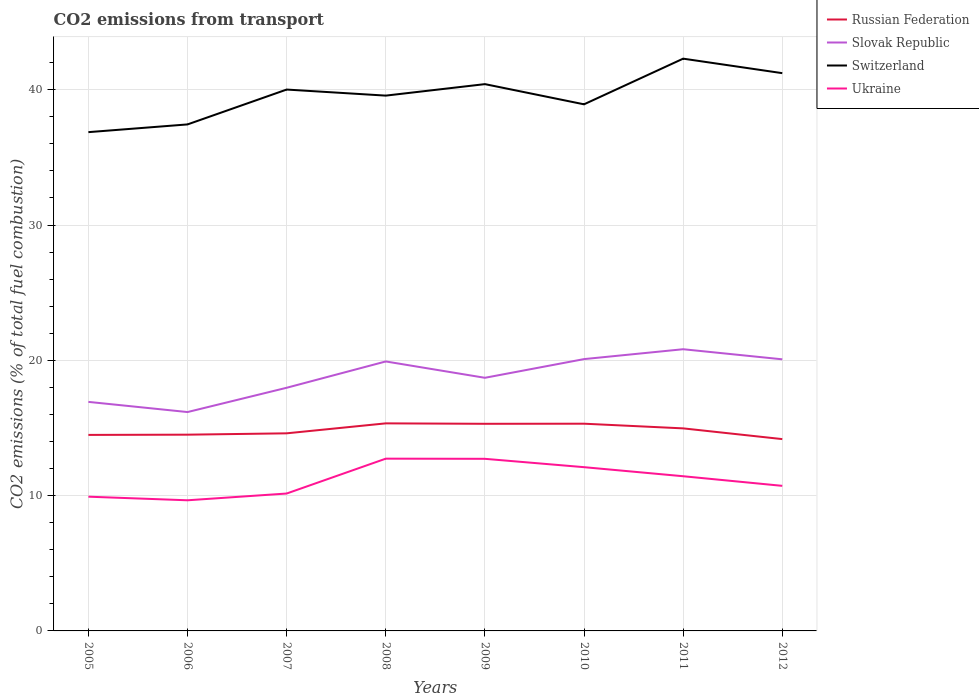How many different coloured lines are there?
Offer a terse response. 4. Does the line corresponding to Ukraine intersect with the line corresponding to Slovak Republic?
Your response must be concise. No. Is the number of lines equal to the number of legend labels?
Your response must be concise. Yes. Across all years, what is the maximum total CO2 emitted in Russian Federation?
Your response must be concise. 14.18. What is the total total CO2 emitted in Switzerland in the graph?
Keep it short and to the point. -2.58. What is the difference between the highest and the second highest total CO2 emitted in Switzerland?
Your response must be concise. 5.43. What is the difference between the highest and the lowest total CO2 emitted in Slovak Republic?
Your answer should be compact. 4. Is the total CO2 emitted in Switzerland strictly greater than the total CO2 emitted in Ukraine over the years?
Provide a succinct answer. No. How many lines are there?
Keep it short and to the point. 4. How many years are there in the graph?
Offer a very short reply. 8. Are the values on the major ticks of Y-axis written in scientific E-notation?
Make the answer very short. No. Does the graph contain any zero values?
Provide a short and direct response. No. Does the graph contain grids?
Ensure brevity in your answer.  Yes. Where does the legend appear in the graph?
Offer a very short reply. Top right. What is the title of the graph?
Give a very brief answer. CO2 emissions from transport. Does "Faeroe Islands" appear as one of the legend labels in the graph?
Give a very brief answer. No. What is the label or title of the Y-axis?
Offer a terse response. CO2 emissions (% of total fuel combustion). What is the CO2 emissions (% of total fuel combustion) in Russian Federation in 2005?
Offer a very short reply. 14.49. What is the CO2 emissions (% of total fuel combustion) in Slovak Republic in 2005?
Give a very brief answer. 16.93. What is the CO2 emissions (% of total fuel combustion) of Switzerland in 2005?
Keep it short and to the point. 36.87. What is the CO2 emissions (% of total fuel combustion) in Ukraine in 2005?
Your response must be concise. 9.92. What is the CO2 emissions (% of total fuel combustion) in Russian Federation in 2006?
Your answer should be compact. 14.51. What is the CO2 emissions (% of total fuel combustion) in Slovak Republic in 2006?
Your answer should be compact. 16.18. What is the CO2 emissions (% of total fuel combustion) of Switzerland in 2006?
Offer a terse response. 37.44. What is the CO2 emissions (% of total fuel combustion) in Ukraine in 2006?
Your response must be concise. 9.66. What is the CO2 emissions (% of total fuel combustion) in Russian Federation in 2007?
Give a very brief answer. 14.61. What is the CO2 emissions (% of total fuel combustion) in Slovak Republic in 2007?
Offer a very short reply. 17.97. What is the CO2 emissions (% of total fuel combustion) of Switzerland in 2007?
Offer a terse response. 40.01. What is the CO2 emissions (% of total fuel combustion) in Ukraine in 2007?
Your answer should be very brief. 10.16. What is the CO2 emissions (% of total fuel combustion) of Russian Federation in 2008?
Give a very brief answer. 15.34. What is the CO2 emissions (% of total fuel combustion) in Slovak Republic in 2008?
Your answer should be compact. 19.92. What is the CO2 emissions (% of total fuel combustion) of Switzerland in 2008?
Give a very brief answer. 39.57. What is the CO2 emissions (% of total fuel combustion) of Ukraine in 2008?
Your answer should be very brief. 12.73. What is the CO2 emissions (% of total fuel combustion) of Russian Federation in 2009?
Offer a very short reply. 15.31. What is the CO2 emissions (% of total fuel combustion) of Slovak Republic in 2009?
Offer a very short reply. 18.71. What is the CO2 emissions (% of total fuel combustion) of Switzerland in 2009?
Your response must be concise. 40.42. What is the CO2 emissions (% of total fuel combustion) in Ukraine in 2009?
Keep it short and to the point. 12.72. What is the CO2 emissions (% of total fuel combustion) of Russian Federation in 2010?
Keep it short and to the point. 15.32. What is the CO2 emissions (% of total fuel combustion) in Slovak Republic in 2010?
Provide a succinct answer. 20.09. What is the CO2 emissions (% of total fuel combustion) of Switzerland in 2010?
Your answer should be compact. 38.92. What is the CO2 emissions (% of total fuel combustion) in Ukraine in 2010?
Offer a terse response. 12.1. What is the CO2 emissions (% of total fuel combustion) in Russian Federation in 2011?
Your answer should be compact. 14.97. What is the CO2 emissions (% of total fuel combustion) in Slovak Republic in 2011?
Offer a very short reply. 20.82. What is the CO2 emissions (% of total fuel combustion) in Switzerland in 2011?
Your answer should be compact. 42.3. What is the CO2 emissions (% of total fuel combustion) of Ukraine in 2011?
Your answer should be compact. 11.43. What is the CO2 emissions (% of total fuel combustion) in Russian Federation in 2012?
Provide a short and direct response. 14.18. What is the CO2 emissions (% of total fuel combustion) in Slovak Republic in 2012?
Your answer should be very brief. 20.08. What is the CO2 emissions (% of total fuel combustion) of Switzerland in 2012?
Give a very brief answer. 41.23. What is the CO2 emissions (% of total fuel combustion) of Ukraine in 2012?
Provide a short and direct response. 10.72. Across all years, what is the maximum CO2 emissions (% of total fuel combustion) of Russian Federation?
Keep it short and to the point. 15.34. Across all years, what is the maximum CO2 emissions (% of total fuel combustion) in Slovak Republic?
Keep it short and to the point. 20.82. Across all years, what is the maximum CO2 emissions (% of total fuel combustion) in Switzerland?
Offer a terse response. 42.3. Across all years, what is the maximum CO2 emissions (% of total fuel combustion) of Ukraine?
Provide a short and direct response. 12.73. Across all years, what is the minimum CO2 emissions (% of total fuel combustion) of Russian Federation?
Offer a terse response. 14.18. Across all years, what is the minimum CO2 emissions (% of total fuel combustion) in Slovak Republic?
Give a very brief answer. 16.18. Across all years, what is the minimum CO2 emissions (% of total fuel combustion) of Switzerland?
Your answer should be very brief. 36.87. Across all years, what is the minimum CO2 emissions (% of total fuel combustion) in Ukraine?
Offer a terse response. 9.66. What is the total CO2 emissions (% of total fuel combustion) in Russian Federation in the graph?
Provide a succinct answer. 118.72. What is the total CO2 emissions (% of total fuel combustion) of Slovak Republic in the graph?
Make the answer very short. 150.69. What is the total CO2 emissions (% of total fuel combustion) of Switzerland in the graph?
Your answer should be compact. 316.75. What is the total CO2 emissions (% of total fuel combustion) of Ukraine in the graph?
Ensure brevity in your answer.  89.45. What is the difference between the CO2 emissions (% of total fuel combustion) in Russian Federation in 2005 and that in 2006?
Ensure brevity in your answer.  -0.02. What is the difference between the CO2 emissions (% of total fuel combustion) of Slovak Republic in 2005 and that in 2006?
Provide a short and direct response. 0.75. What is the difference between the CO2 emissions (% of total fuel combustion) in Switzerland in 2005 and that in 2006?
Offer a terse response. -0.57. What is the difference between the CO2 emissions (% of total fuel combustion) in Ukraine in 2005 and that in 2006?
Your response must be concise. 0.27. What is the difference between the CO2 emissions (% of total fuel combustion) in Russian Federation in 2005 and that in 2007?
Provide a succinct answer. -0.12. What is the difference between the CO2 emissions (% of total fuel combustion) of Slovak Republic in 2005 and that in 2007?
Your answer should be very brief. -1.04. What is the difference between the CO2 emissions (% of total fuel combustion) of Switzerland in 2005 and that in 2007?
Offer a terse response. -3.15. What is the difference between the CO2 emissions (% of total fuel combustion) in Ukraine in 2005 and that in 2007?
Offer a terse response. -0.23. What is the difference between the CO2 emissions (% of total fuel combustion) of Russian Federation in 2005 and that in 2008?
Offer a very short reply. -0.85. What is the difference between the CO2 emissions (% of total fuel combustion) of Slovak Republic in 2005 and that in 2008?
Your answer should be very brief. -2.99. What is the difference between the CO2 emissions (% of total fuel combustion) of Switzerland in 2005 and that in 2008?
Your response must be concise. -2.7. What is the difference between the CO2 emissions (% of total fuel combustion) of Ukraine in 2005 and that in 2008?
Your answer should be compact. -2.81. What is the difference between the CO2 emissions (% of total fuel combustion) of Russian Federation in 2005 and that in 2009?
Keep it short and to the point. -0.82. What is the difference between the CO2 emissions (% of total fuel combustion) of Slovak Republic in 2005 and that in 2009?
Your response must be concise. -1.78. What is the difference between the CO2 emissions (% of total fuel combustion) of Switzerland in 2005 and that in 2009?
Provide a succinct answer. -3.55. What is the difference between the CO2 emissions (% of total fuel combustion) of Ukraine in 2005 and that in 2009?
Keep it short and to the point. -2.8. What is the difference between the CO2 emissions (% of total fuel combustion) in Russian Federation in 2005 and that in 2010?
Provide a succinct answer. -0.83. What is the difference between the CO2 emissions (% of total fuel combustion) of Slovak Republic in 2005 and that in 2010?
Your answer should be very brief. -3.16. What is the difference between the CO2 emissions (% of total fuel combustion) in Switzerland in 2005 and that in 2010?
Your response must be concise. -2.06. What is the difference between the CO2 emissions (% of total fuel combustion) of Ukraine in 2005 and that in 2010?
Keep it short and to the point. -2.18. What is the difference between the CO2 emissions (% of total fuel combustion) in Russian Federation in 2005 and that in 2011?
Provide a succinct answer. -0.48. What is the difference between the CO2 emissions (% of total fuel combustion) in Slovak Republic in 2005 and that in 2011?
Make the answer very short. -3.89. What is the difference between the CO2 emissions (% of total fuel combustion) of Switzerland in 2005 and that in 2011?
Give a very brief answer. -5.43. What is the difference between the CO2 emissions (% of total fuel combustion) of Ukraine in 2005 and that in 2011?
Your answer should be compact. -1.51. What is the difference between the CO2 emissions (% of total fuel combustion) in Russian Federation in 2005 and that in 2012?
Provide a short and direct response. 0.31. What is the difference between the CO2 emissions (% of total fuel combustion) of Slovak Republic in 2005 and that in 2012?
Make the answer very short. -3.15. What is the difference between the CO2 emissions (% of total fuel combustion) of Switzerland in 2005 and that in 2012?
Provide a short and direct response. -4.36. What is the difference between the CO2 emissions (% of total fuel combustion) of Ukraine in 2005 and that in 2012?
Your response must be concise. -0.8. What is the difference between the CO2 emissions (% of total fuel combustion) of Russian Federation in 2006 and that in 2007?
Offer a terse response. -0.1. What is the difference between the CO2 emissions (% of total fuel combustion) of Slovak Republic in 2006 and that in 2007?
Your response must be concise. -1.8. What is the difference between the CO2 emissions (% of total fuel combustion) of Switzerland in 2006 and that in 2007?
Offer a very short reply. -2.58. What is the difference between the CO2 emissions (% of total fuel combustion) in Ukraine in 2006 and that in 2007?
Offer a terse response. -0.5. What is the difference between the CO2 emissions (% of total fuel combustion) of Russian Federation in 2006 and that in 2008?
Give a very brief answer. -0.84. What is the difference between the CO2 emissions (% of total fuel combustion) of Slovak Republic in 2006 and that in 2008?
Your response must be concise. -3.74. What is the difference between the CO2 emissions (% of total fuel combustion) of Switzerland in 2006 and that in 2008?
Your answer should be very brief. -2.13. What is the difference between the CO2 emissions (% of total fuel combustion) in Ukraine in 2006 and that in 2008?
Provide a short and direct response. -3.08. What is the difference between the CO2 emissions (% of total fuel combustion) in Russian Federation in 2006 and that in 2009?
Offer a very short reply. -0.8. What is the difference between the CO2 emissions (% of total fuel combustion) in Slovak Republic in 2006 and that in 2009?
Provide a short and direct response. -2.53. What is the difference between the CO2 emissions (% of total fuel combustion) in Switzerland in 2006 and that in 2009?
Keep it short and to the point. -2.98. What is the difference between the CO2 emissions (% of total fuel combustion) of Ukraine in 2006 and that in 2009?
Provide a short and direct response. -3.06. What is the difference between the CO2 emissions (% of total fuel combustion) of Russian Federation in 2006 and that in 2010?
Make the answer very short. -0.81. What is the difference between the CO2 emissions (% of total fuel combustion) of Slovak Republic in 2006 and that in 2010?
Provide a succinct answer. -3.91. What is the difference between the CO2 emissions (% of total fuel combustion) of Switzerland in 2006 and that in 2010?
Your response must be concise. -1.49. What is the difference between the CO2 emissions (% of total fuel combustion) of Ukraine in 2006 and that in 2010?
Ensure brevity in your answer.  -2.45. What is the difference between the CO2 emissions (% of total fuel combustion) of Russian Federation in 2006 and that in 2011?
Offer a terse response. -0.47. What is the difference between the CO2 emissions (% of total fuel combustion) in Slovak Republic in 2006 and that in 2011?
Make the answer very short. -4.64. What is the difference between the CO2 emissions (% of total fuel combustion) of Switzerland in 2006 and that in 2011?
Offer a very short reply. -4.86. What is the difference between the CO2 emissions (% of total fuel combustion) in Ukraine in 2006 and that in 2011?
Make the answer very short. -1.78. What is the difference between the CO2 emissions (% of total fuel combustion) of Russian Federation in 2006 and that in 2012?
Your answer should be very brief. 0.33. What is the difference between the CO2 emissions (% of total fuel combustion) in Slovak Republic in 2006 and that in 2012?
Provide a short and direct response. -3.9. What is the difference between the CO2 emissions (% of total fuel combustion) of Switzerland in 2006 and that in 2012?
Your answer should be very brief. -3.79. What is the difference between the CO2 emissions (% of total fuel combustion) of Ukraine in 2006 and that in 2012?
Offer a very short reply. -1.07. What is the difference between the CO2 emissions (% of total fuel combustion) of Russian Federation in 2007 and that in 2008?
Your answer should be very brief. -0.74. What is the difference between the CO2 emissions (% of total fuel combustion) of Slovak Republic in 2007 and that in 2008?
Your answer should be compact. -1.95. What is the difference between the CO2 emissions (% of total fuel combustion) in Switzerland in 2007 and that in 2008?
Your response must be concise. 0.45. What is the difference between the CO2 emissions (% of total fuel combustion) in Ukraine in 2007 and that in 2008?
Make the answer very short. -2.58. What is the difference between the CO2 emissions (% of total fuel combustion) in Russian Federation in 2007 and that in 2009?
Provide a succinct answer. -0.7. What is the difference between the CO2 emissions (% of total fuel combustion) in Slovak Republic in 2007 and that in 2009?
Offer a terse response. -0.74. What is the difference between the CO2 emissions (% of total fuel combustion) in Switzerland in 2007 and that in 2009?
Give a very brief answer. -0.4. What is the difference between the CO2 emissions (% of total fuel combustion) in Ukraine in 2007 and that in 2009?
Give a very brief answer. -2.57. What is the difference between the CO2 emissions (% of total fuel combustion) of Russian Federation in 2007 and that in 2010?
Offer a terse response. -0.71. What is the difference between the CO2 emissions (% of total fuel combustion) in Slovak Republic in 2007 and that in 2010?
Keep it short and to the point. -2.12. What is the difference between the CO2 emissions (% of total fuel combustion) in Switzerland in 2007 and that in 2010?
Keep it short and to the point. 1.09. What is the difference between the CO2 emissions (% of total fuel combustion) of Ukraine in 2007 and that in 2010?
Keep it short and to the point. -1.95. What is the difference between the CO2 emissions (% of total fuel combustion) of Russian Federation in 2007 and that in 2011?
Provide a short and direct response. -0.37. What is the difference between the CO2 emissions (% of total fuel combustion) in Slovak Republic in 2007 and that in 2011?
Provide a short and direct response. -2.85. What is the difference between the CO2 emissions (% of total fuel combustion) of Switzerland in 2007 and that in 2011?
Make the answer very short. -2.28. What is the difference between the CO2 emissions (% of total fuel combustion) in Ukraine in 2007 and that in 2011?
Keep it short and to the point. -1.28. What is the difference between the CO2 emissions (% of total fuel combustion) in Russian Federation in 2007 and that in 2012?
Provide a short and direct response. 0.43. What is the difference between the CO2 emissions (% of total fuel combustion) in Slovak Republic in 2007 and that in 2012?
Make the answer very short. -2.1. What is the difference between the CO2 emissions (% of total fuel combustion) of Switzerland in 2007 and that in 2012?
Provide a succinct answer. -1.21. What is the difference between the CO2 emissions (% of total fuel combustion) in Ukraine in 2007 and that in 2012?
Provide a short and direct response. -0.57. What is the difference between the CO2 emissions (% of total fuel combustion) in Russian Federation in 2008 and that in 2009?
Provide a succinct answer. 0.03. What is the difference between the CO2 emissions (% of total fuel combustion) of Slovak Republic in 2008 and that in 2009?
Your response must be concise. 1.21. What is the difference between the CO2 emissions (% of total fuel combustion) of Switzerland in 2008 and that in 2009?
Give a very brief answer. -0.85. What is the difference between the CO2 emissions (% of total fuel combustion) of Ukraine in 2008 and that in 2009?
Make the answer very short. 0.01. What is the difference between the CO2 emissions (% of total fuel combustion) of Russian Federation in 2008 and that in 2010?
Provide a short and direct response. 0.03. What is the difference between the CO2 emissions (% of total fuel combustion) in Slovak Republic in 2008 and that in 2010?
Offer a terse response. -0.17. What is the difference between the CO2 emissions (% of total fuel combustion) of Switzerland in 2008 and that in 2010?
Make the answer very short. 0.64. What is the difference between the CO2 emissions (% of total fuel combustion) of Ukraine in 2008 and that in 2010?
Offer a very short reply. 0.63. What is the difference between the CO2 emissions (% of total fuel combustion) in Russian Federation in 2008 and that in 2011?
Your answer should be very brief. 0.37. What is the difference between the CO2 emissions (% of total fuel combustion) in Slovak Republic in 2008 and that in 2011?
Provide a short and direct response. -0.9. What is the difference between the CO2 emissions (% of total fuel combustion) of Switzerland in 2008 and that in 2011?
Offer a very short reply. -2.73. What is the difference between the CO2 emissions (% of total fuel combustion) in Ukraine in 2008 and that in 2011?
Offer a very short reply. 1.3. What is the difference between the CO2 emissions (% of total fuel combustion) of Russian Federation in 2008 and that in 2012?
Your response must be concise. 1.16. What is the difference between the CO2 emissions (% of total fuel combustion) of Slovak Republic in 2008 and that in 2012?
Offer a very short reply. -0.16. What is the difference between the CO2 emissions (% of total fuel combustion) of Switzerland in 2008 and that in 2012?
Your answer should be very brief. -1.66. What is the difference between the CO2 emissions (% of total fuel combustion) of Ukraine in 2008 and that in 2012?
Give a very brief answer. 2.01. What is the difference between the CO2 emissions (% of total fuel combustion) of Russian Federation in 2009 and that in 2010?
Provide a short and direct response. -0.01. What is the difference between the CO2 emissions (% of total fuel combustion) in Slovak Republic in 2009 and that in 2010?
Provide a succinct answer. -1.38. What is the difference between the CO2 emissions (% of total fuel combustion) in Switzerland in 2009 and that in 2010?
Your answer should be compact. 1.49. What is the difference between the CO2 emissions (% of total fuel combustion) of Ukraine in 2009 and that in 2010?
Keep it short and to the point. 0.62. What is the difference between the CO2 emissions (% of total fuel combustion) in Russian Federation in 2009 and that in 2011?
Keep it short and to the point. 0.34. What is the difference between the CO2 emissions (% of total fuel combustion) of Slovak Republic in 2009 and that in 2011?
Provide a succinct answer. -2.11. What is the difference between the CO2 emissions (% of total fuel combustion) in Switzerland in 2009 and that in 2011?
Your answer should be very brief. -1.88. What is the difference between the CO2 emissions (% of total fuel combustion) in Ukraine in 2009 and that in 2011?
Provide a succinct answer. 1.29. What is the difference between the CO2 emissions (% of total fuel combustion) in Russian Federation in 2009 and that in 2012?
Provide a succinct answer. 1.13. What is the difference between the CO2 emissions (% of total fuel combustion) of Slovak Republic in 2009 and that in 2012?
Offer a terse response. -1.37. What is the difference between the CO2 emissions (% of total fuel combustion) of Switzerland in 2009 and that in 2012?
Provide a short and direct response. -0.81. What is the difference between the CO2 emissions (% of total fuel combustion) of Ukraine in 2009 and that in 2012?
Your response must be concise. 2. What is the difference between the CO2 emissions (% of total fuel combustion) in Russian Federation in 2010 and that in 2011?
Provide a succinct answer. 0.35. What is the difference between the CO2 emissions (% of total fuel combustion) of Slovak Republic in 2010 and that in 2011?
Keep it short and to the point. -0.73. What is the difference between the CO2 emissions (% of total fuel combustion) in Switzerland in 2010 and that in 2011?
Offer a terse response. -3.37. What is the difference between the CO2 emissions (% of total fuel combustion) of Ukraine in 2010 and that in 2011?
Your response must be concise. 0.67. What is the difference between the CO2 emissions (% of total fuel combustion) of Russian Federation in 2010 and that in 2012?
Give a very brief answer. 1.14. What is the difference between the CO2 emissions (% of total fuel combustion) in Slovak Republic in 2010 and that in 2012?
Offer a terse response. 0.02. What is the difference between the CO2 emissions (% of total fuel combustion) of Switzerland in 2010 and that in 2012?
Offer a terse response. -2.3. What is the difference between the CO2 emissions (% of total fuel combustion) in Ukraine in 2010 and that in 2012?
Offer a very short reply. 1.38. What is the difference between the CO2 emissions (% of total fuel combustion) of Russian Federation in 2011 and that in 2012?
Make the answer very short. 0.79. What is the difference between the CO2 emissions (% of total fuel combustion) in Slovak Republic in 2011 and that in 2012?
Your answer should be compact. 0.75. What is the difference between the CO2 emissions (% of total fuel combustion) of Switzerland in 2011 and that in 2012?
Keep it short and to the point. 1.07. What is the difference between the CO2 emissions (% of total fuel combustion) in Ukraine in 2011 and that in 2012?
Provide a short and direct response. 0.71. What is the difference between the CO2 emissions (% of total fuel combustion) of Russian Federation in 2005 and the CO2 emissions (% of total fuel combustion) of Slovak Republic in 2006?
Make the answer very short. -1.69. What is the difference between the CO2 emissions (% of total fuel combustion) in Russian Federation in 2005 and the CO2 emissions (% of total fuel combustion) in Switzerland in 2006?
Keep it short and to the point. -22.95. What is the difference between the CO2 emissions (% of total fuel combustion) of Russian Federation in 2005 and the CO2 emissions (% of total fuel combustion) of Ukraine in 2006?
Provide a succinct answer. 4.83. What is the difference between the CO2 emissions (% of total fuel combustion) in Slovak Republic in 2005 and the CO2 emissions (% of total fuel combustion) in Switzerland in 2006?
Your answer should be compact. -20.51. What is the difference between the CO2 emissions (% of total fuel combustion) of Slovak Republic in 2005 and the CO2 emissions (% of total fuel combustion) of Ukraine in 2006?
Keep it short and to the point. 7.27. What is the difference between the CO2 emissions (% of total fuel combustion) of Switzerland in 2005 and the CO2 emissions (% of total fuel combustion) of Ukraine in 2006?
Make the answer very short. 27.21. What is the difference between the CO2 emissions (% of total fuel combustion) in Russian Federation in 2005 and the CO2 emissions (% of total fuel combustion) in Slovak Republic in 2007?
Provide a short and direct response. -3.48. What is the difference between the CO2 emissions (% of total fuel combustion) of Russian Federation in 2005 and the CO2 emissions (% of total fuel combustion) of Switzerland in 2007?
Keep it short and to the point. -25.53. What is the difference between the CO2 emissions (% of total fuel combustion) of Russian Federation in 2005 and the CO2 emissions (% of total fuel combustion) of Ukraine in 2007?
Offer a terse response. 4.33. What is the difference between the CO2 emissions (% of total fuel combustion) in Slovak Republic in 2005 and the CO2 emissions (% of total fuel combustion) in Switzerland in 2007?
Provide a succinct answer. -23.09. What is the difference between the CO2 emissions (% of total fuel combustion) of Slovak Republic in 2005 and the CO2 emissions (% of total fuel combustion) of Ukraine in 2007?
Your answer should be compact. 6.77. What is the difference between the CO2 emissions (% of total fuel combustion) of Switzerland in 2005 and the CO2 emissions (% of total fuel combustion) of Ukraine in 2007?
Provide a succinct answer. 26.71. What is the difference between the CO2 emissions (% of total fuel combustion) in Russian Federation in 2005 and the CO2 emissions (% of total fuel combustion) in Slovak Republic in 2008?
Keep it short and to the point. -5.43. What is the difference between the CO2 emissions (% of total fuel combustion) of Russian Federation in 2005 and the CO2 emissions (% of total fuel combustion) of Switzerland in 2008?
Give a very brief answer. -25.08. What is the difference between the CO2 emissions (% of total fuel combustion) in Russian Federation in 2005 and the CO2 emissions (% of total fuel combustion) in Ukraine in 2008?
Your answer should be very brief. 1.76. What is the difference between the CO2 emissions (% of total fuel combustion) in Slovak Republic in 2005 and the CO2 emissions (% of total fuel combustion) in Switzerland in 2008?
Provide a succinct answer. -22.64. What is the difference between the CO2 emissions (% of total fuel combustion) of Slovak Republic in 2005 and the CO2 emissions (% of total fuel combustion) of Ukraine in 2008?
Offer a terse response. 4.2. What is the difference between the CO2 emissions (% of total fuel combustion) in Switzerland in 2005 and the CO2 emissions (% of total fuel combustion) in Ukraine in 2008?
Make the answer very short. 24.13. What is the difference between the CO2 emissions (% of total fuel combustion) in Russian Federation in 2005 and the CO2 emissions (% of total fuel combustion) in Slovak Republic in 2009?
Your response must be concise. -4.22. What is the difference between the CO2 emissions (% of total fuel combustion) of Russian Federation in 2005 and the CO2 emissions (% of total fuel combustion) of Switzerland in 2009?
Ensure brevity in your answer.  -25.93. What is the difference between the CO2 emissions (% of total fuel combustion) in Russian Federation in 2005 and the CO2 emissions (% of total fuel combustion) in Ukraine in 2009?
Give a very brief answer. 1.77. What is the difference between the CO2 emissions (% of total fuel combustion) of Slovak Republic in 2005 and the CO2 emissions (% of total fuel combustion) of Switzerland in 2009?
Your answer should be very brief. -23.49. What is the difference between the CO2 emissions (% of total fuel combustion) in Slovak Republic in 2005 and the CO2 emissions (% of total fuel combustion) in Ukraine in 2009?
Your answer should be very brief. 4.21. What is the difference between the CO2 emissions (% of total fuel combustion) in Switzerland in 2005 and the CO2 emissions (% of total fuel combustion) in Ukraine in 2009?
Your answer should be compact. 24.15. What is the difference between the CO2 emissions (% of total fuel combustion) in Russian Federation in 2005 and the CO2 emissions (% of total fuel combustion) in Slovak Republic in 2010?
Keep it short and to the point. -5.6. What is the difference between the CO2 emissions (% of total fuel combustion) in Russian Federation in 2005 and the CO2 emissions (% of total fuel combustion) in Switzerland in 2010?
Provide a short and direct response. -24.43. What is the difference between the CO2 emissions (% of total fuel combustion) in Russian Federation in 2005 and the CO2 emissions (% of total fuel combustion) in Ukraine in 2010?
Give a very brief answer. 2.38. What is the difference between the CO2 emissions (% of total fuel combustion) of Slovak Republic in 2005 and the CO2 emissions (% of total fuel combustion) of Switzerland in 2010?
Your response must be concise. -21.99. What is the difference between the CO2 emissions (% of total fuel combustion) of Slovak Republic in 2005 and the CO2 emissions (% of total fuel combustion) of Ukraine in 2010?
Your answer should be very brief. 4.83. What is the difference between the CO2 emissions (% of total fuel combustion) in Switzerland in 2005 and the CO2 emissions (% of total fuel combustion) in Ukraine in 2010?
Make the answer very short. 24.76. What is the difference between the CO2 emissions (% of total fuel combustion) of Russian Federation in 2005 and the CO2 emissions (% of total fuel combustion) of Slovak Republic in 2011?
Provide a short and direct response. -6.33. What is the difference between the CO2 emissions (% of total fuel combustion) of Russian Federation in 2005 and the CO2 emissions (% of total fuel combustion) of Switzerland in 2011?
Your answer should be compact. -27.81. What is the difference between the CO2 emissions (% of total fuel combustion) of Russian Federation in 2005 and the CO2 emissions (% of total fuel combustion) of Ukraine in 2011?
Keep it short and to the point. 3.05. What is the difference between the CO2 emissions (% of total fuel combustion) of Slovak Republic in 2005 and the CO2 emissions (% of total fuel combustion) of Switzerland in 2011?
Offer a terse response. -25.37. What is the difference between the CO2 emissions (% of total fuel combustion) of Slovak Republic in 2005 and the CO2 emissions (% of total fuel combustion) of Ukraine in 2011?
Your response must be concise. 5.5. What is the difference between the CO2 emissions (% of total fuel combustion) in Switzerland in 2005 and the CO2 emissions (% of total fuel combustion) in Ukraine in 2011?
Offer a very short reply. 25.43. What is the difference between the CO2 emissions (% of total fuel combustion) in Russian Federation in 2005 and the CO2 emissions (% of total fuel combustion) in Slovak Republic in 2012?
Make the answer very short. -5.59. What is the difference between the CO2 emissions (% of total fuel combustion) in Russian Federation in 2005 and the CO2 emissions (% of total fuel combustion) in Switzerland in 2012?
Ensure brevity in your answer.  -26.74. What is the difference between the CO2 emissions (% of total fuel combustion) in Russian Federation in 2005 and the CO2 emissions (% of total fuel combustion) in Ukraine in 2012?
Your answer should be compact. 3.77. What is the difference between the CO2 emissions (% of total fuel combustion) of Slovak Republic in 2005 and the CO2 emissions (% of total fuel combustion) of Switzerland in 2012?
Offer a very short reply. -24.3. What is the difference between the CO2 emissions (% of total fuel combustion) in Slovak Republic in 2005 and the CO2 emissions (% of total fuel combustion) in Ukraine in 2012?
Offer a very short reply. 6.21. What is the difference between the CO2 emissions (% of total fuel combustion) in Switzerland in 2005 and the CO2 emissions (% of total fuel combustion) in Ukraine in 2012?
Offer a very short reply. 26.14. What is the difference between the CO2 emissions (% of total fuel combustion) in Russian Federation in 2006 and the CO2 emissions (% of total fuel combustion) in Slovak Republic in 2007?
Offer a terse response. -3.47. What is the difference between the CO2 emissions (% of total fuel combustion) in Russian Federation in 2006 and the CO2 emissions (% of total fuel combustion) in Switzerland in 2007?
Your response must be concise. -25.51. What is the difference between the CO2 emissions (% of total fuel combustion) of Russian Federation in 2006 and the CO2 emissions (% of total fuel combustion) of Ukraine in 2007?
Keep it short and to the point. 4.35. What is the difference between the CO2 emissions (% of total fuel combustion) of Slovak Republic in 2006 and the CO2 emissions (% of total fuel combustion) of Switzerland in 2007?
Provide a succinct answer. -23.84. What is the difference between the CO2 emissions (% of total fuel combustion) of Slovak Republic in 2006 and the CO2 emissions (% of total fuel combustion) of Ukraine in 2007?
Your answer should be compact. 6.02. What is the difference between the CO2 emissions (% of total fuel combustion) in Switzerland in 2006 and the CO2 emissions (% of total fuel combustion) in Ukraine in 2007?
Your answer should be very brief. 27.28. What is the difference between the CO2 emissions (% of total fuel combustion) in Russian Federation in 2006 and the CO2 emissions (% of total fuel combustion) in Slovak Republic in 2008?
Ensure brevity in your answer.  -5.41. What is the difference between the CO2 emissions (% of total fuel combustion) in Russian Federation in 2006 and the CO2 emissions (% of total fuel combustion) in Switzerland in 2008?
Offer a very short reply. -25.06. What is the difference between the CO2 emissions (% of total fuel combustion) in Russian Federation in 2006 and the CO2 emissions (% of total fuel combustion) in Ukraine in 2008?
Give a very brief answer. 1.77. What is the difference between the CO2 emissions (% of total fuel combustion) in Slovak Republic in 2006 and the CO2 emissions (% of total fuel combustion) in Switzerland in 2008?
Provide a succinct answer. -23.39. What is the difference between the CO2 emissions (% of total fuel combustion) of Slovak Republic in 2006 and the CO2 emissions (% of total fuel combustion) of Ukraine in 2008?
Your answer should be very brief. 3.44. What is the difference between the CO2 emissions (% of total fuel combustion) of Switzerland in 2006 and the CO2 emissions (% of total fuel combustion) of Ukraine in 2008?
Keep it short and to the point. 24.71. What is the difference between the CO2 emissions (% of total fuel combustion) in Russian Federation in 2006 and the CO2 emissions (% of total fuel combustion) in Slovak Republic in 2009?
Your answer should be compact. -4.2. What is the difference between the CO2 emissions (% of total fuel combustion) in Russian Federation in 2006 and the CO2 emissions (% of total fuel combustion) in Switzerland in 2009?
Give a very brief answer. -25.91. What is the difference between the CO2 emissions (% of total fuel combustion) in Russian Federation in 2006 and the CO2 emissions (% of total fuel combustion) in Ukraine in 2009?
Your answer should be compact. 1.78. What is the difference between the CO2 emissions (% of total fuel combustion) in Slovak Republic in 2006 and the CO2 emissions (% of total fuel combustion) in Switzerland in 2009?
Make the answer very short. -24.24. What is the difference between the CO2 emissions (% of total fuel combustion) in Slovak Republic in 2006 and the CO2 emissions (% of total fuel combustion) in Ukraine in 2009?
Offer a terse response. 3.46. What is the difference between the CO2 emissions (% of total fuel combustion) of Switzerland in 2006 and the CO2 emissions (% of total fuel combustion) of Ukraine in 2009?
Make the answer very short. 24.72. What is the difference between the CO2 emissions (% of total fuel combustion) of Russian Federation in 2006 and the CO2 emissions (% of total fuel combustion) of Slovak Republic in 2010?
Your answer should be very brief. -5.59. What is the difference between the CO2 emissions (% of total fuel combustion) in Russian Federation in 2006 and the CO2 emissions (% of total fuel combustion) in Switzerland in 2010?
Ensure brevity in your answer.  -24.42. What is the difference between the CO2 emissions (% of total fuel combustion) of Russian Federation in 2006 and the CO2 emissions (% of total fuel combustion) of Ukraine in 2010?
Offer a terse response. 2.4. What is the difference between the CO2 emissions (% of total fuel combustion) in Slovak Republic in 2006 and the CO2 emissions (% of total fuel combustion) in Switzerland in 2010?
Offer a very short reply. -22.75. What is the difference between the CO2 emissions (% of total fuel combustion) in Slovak Republic in 2006 and the CO2 emissions (% of total fuel combustion) in Ukraine in 2010?
Provide a succinct answer. 4.07. What is the difference between the CO2 emissions (% of total fuel combustion) in Switzerland in 2006 and the CO2 emissions (% of total fuel combustion) in Ukraine in 2010?
Offer a terse response. 25.33. What is the difference between the CO2 emissions (% of total fuel combustion) in Russian Federation in 2006 and the CO2 emissions (% of total fuel combustion) in Slovak Republic in 2011?
Provide a succinct answer. -6.32. What is the difference between the CO2 emissions (% of total fuel combustion) of Russian Federation in 2006 and the CO2 emissions (% of total fuel combustion) of Switzerland in 2011?
Offer a very short reply. -27.79. What is the difference between the CO2 emissions (% of total fuel combustion) in Russian Federation in 2006 and the CO2 emissions (% of total fuel combustion) in Ukraine in 2011?
Provide a short and direct response. 3.07. What is the difference between the CO2 emissions (% of total fuel combustion) of Slovak Republic in 2006 and the CO2 emissions (% of total fuel combustion) of Switzerland in 2011?
Your response must be concise. -26.12. What is the difference between the CO2 emissions (% of total fuel combustion) in Slovak Republic in 2006 and the CO2 emissions (% of total fuel combustion) in Ukraine in 2011?
Keep it short and to the point. 4.74. What is the difference between the CO2 emissions (% of total fuel combustion) in Switzerland in 2006 and the CO2 emissions (% of total fuel combustion) in Ukraine in 2011?
Ensure brevity in your answer.  26. What is the difference between the CO2 emissions (% of total fuel combustion) in Russian Federation in 2006 and the CO2 emissions (% of total fuel combustion) in Slovak Republic in 2012?
Make the answer very short. -5.57. What is the difference between the CO2 emissions (% of total fuel combustion) in Russian Federation in 2006 and the CO2 emissions (% of total fuel combustion) in Switzerland in 2012?
Keep it short and to the point. -26.72. What is the difference between the CO2 emissions (% of total fuel combustion) in Russian Federation in 2006 and the CO2 emissions (% of total fuel combustion) in Ukraine in 2012?
Offer a terse response. 3.78. What is the difference between the CO2 emissions (% of total fuel combustion) of Slovak Republic in 2006 and the CO2 emissions (% of total fuel combustion) of Switzerland in 2012?
Your response must be concise. -25.05. What is the difference between the CO2 emissions (% of total fuel combustion) in Slovak Republic in 2006 and the CO2 emissions (% of total fuel combustion) in Ukraine in 2012?
Your response must be concise. 5.45. What is the difference between the CO2 emissions (% of total fuel combustion) of Switzerland in 2006 and the CO2 emissions (% of total fuel combustion) of Ukraine in 2012?
Your answer should be compact. 26.71. What is the difference between the CO2 emissions (% of total fuel combustion) of Russian Federation in 2007 and the CO2 emissions (% of total fuel combustion) of Slovak Republic in 2008?
Provide a succinct answer. -5.31. What is the difference between the CO2 emissions (% of total fuel combustion) in Russian Federation in 2007 and the CO2 emissions (% of total fuel combustion) in Switzerland in 2008?
Offer a very short reply. -24.96. What is the difference between the CO2 emissions (% of total fuel combustion) of Russian Federation in 2007 and the CO2 emissions (% of total fuel combustion) of Ukraine in 2008?
Provide a short and direct response. 1.87. What is the difference between the CO2 emissions (% of total fuel combustion) of Slovak Republic in 2007 and the CO2 emissions (% of total fuel combustion) of Switzerland in 2008?
Give a very brief answer. -21.59. What is the difference between the CO2 emissions (% of total fuel combustion) in Slovak Republic in 2007 and the CO2 emissions (% of total fuel combustion) in Ukraine in 2008?
Provide a succinct answer. 5.24. What is the difference between the CO2 emissions (% of total fuel combustion) of Switzerland in 2007 and the CO2 emissions (% of total fuel combustion) of Ukraine in 2008?
Offer a very short reply. 27.28. What is the difference between the CO2 emissions (% of total fuel combustion) of Russian Federation in 2007 and the CO2 emissions (% of total fuel combustion) of Slovak Republic in 2009?
Provide a short and direct response. -4.1. What is the difference between the CO2 emissions (% of total fuel combustion) of Russian Federation in 2007 and the CO2 emissions (% of total fuel combustion) of Switzerland in 2009?
Provide a short and direct response. -25.81. What is the difference between the CO2 emissions (% of total fuel combustion) in Russian Federation in 2007 and the CO2 emissions (% of total fuel combustion) in Ukraine in 2009?
Give a very brief answer. 1.88. What is the difference between the CO2 emissions (% of total fuel combustion) in Slovak Republic in 2007 and the CO2 emissions (% of total fuel combustion) in Switzerland in 2009?
Your answer should be very brief. -22.44. What is the difference between the CO2 emissions (% of total fuel combustion) in Slovak Republic in 2007 and the CO2 emissions (% of total fuel combustion) in Ukraine in 2009?
Give a very brief answer. 5.25. What is the difference between the CO2 emissions (% of total fuel combustion) in Switzerland in 2007 and the CO2 emissions (% of total fuel combustion) in Ukraine in 2009?
Your answer should be very brief. 27.29. What is the difference between the CO2 emissions (% of total fuel combustion) in Russian Federation in 2007 and the CO2 emissions (% of total fuel combustion) in Slovak Republic in 2010?
Offer a very short reply. -5.49. What is the difference between the CO2 emissions (% of total fuel combustion) in Russian Federation in 2007 and the CO2 emissions (% of total fuel combustion) in Switzerland in 2010?
Make the answer very short. -24.32. What is the difference between the CO2 emissions (% of total fuel combustion) of Russian Federation in 2007 and the CO2 emissions (% of total fuel combustion) of Ukraine in 2010?
Offer a terse response. 2.5. What is the difference between the CO2 emissions (% of total fuel combustion) in Slovak Republic in 2007 and the CO2 emissions (% of total fuel combustion) in Switzerland in 2010?
Give a very brief answer. -20.95. What is the difference between the CO2 emissions (% of total fuel combustion) in Slovak Republic in 2007 and the CO2 emissions (% of total fuel combustion) in Ukraine in 2010?
Give a very brief answer. 5.87. What is the difference between the CO2 emissions (% of total fuel combustion) of Switzerland in 2007 and the CO2 emissions (% of total fuel combustion) of Ukraine in 2010?
Make the answer very short. 27.91. What is the difference between the CO2 emissions (% of total fuel combustion) of Russian Federation in 2007 and the CO2 emissions (% of total fuel combustion) of Slovak Republic in 2011?
Provide a short and direct response. -6.22. What is the difference between the CO2 emissions (% of total fuel combustion) in Russian Federation in 2007 and the CO2 emissions (% of total fuel combustion) in Switzerland in 2011?
Provide a short and direct response. -27.69. What is the difference between the CO2 emissions (% of total fuel combustion) in Russian Federation in 2007 and the CO2 emissions (% of total fuel combustion) in Ukraine in 2011?
Offer a terse response. 3.17. What is the difference between the CO2 emissions (% of total fuel combustion) of Slovak Republic in 2007 and the CO2 emissions (% of total fuel combustion) of Switzerland in 2011?
Offer a very short reply. -24.33. What is the difference between the CO2 emissions (% of total fuel combustion) of Slovak Republic in 2007 and the CO2 emissions (% of total fuel combustion) of Ukraine in 2011?
Give a very brief answer. 6.54. What is the difference between the CO2 emissions (% of total fuel combustion) of Switzerland in 2007 and the CO2 emissions (% of total fuel combustion) of Ukraine in 2011?
Provide a succinct answer. 28.58. What is the difference between the CO2 emissions (% of total fuel combustion) of Russian Federation in 2007 and the CO2 emissions (% of total fuel combustion) of Slovak Republic in 2012?
Keep it short and to the point. -5.47. What is the difference between the CO2 emissions (% of total fuel combustion) in Russian Federation in 2007 and the CO2 emissions (% of total fuel combustion) in Switzerland in 2012?
Make the answer very short. -26.62. What is the difference between the CO2 emissions (% of total fuel combustion) of Russian Federation in 2007 and the CO2 emissions (% of total fuel combustion) of Ukraine in 2012?
Your answer should be compact. 3.88. What is the difference between the CO2 emissions (% of total fuel combustion) of Slovak Republic in 2007 and the CO2 emissions (% of total fuel combustion) of Switzerland in 2012?
Make the answer very short. -23.25. What is the difference between the CO2 emissions (% of total fuel combustion) of Slovak Republic in 2007 and the CO2 emissions (% of total fuel combustion) of Ukraine in 2012?
Provide a succinct answer. 7.25. What is the difference between the CO2 emissions (% of total fuel combustion) in Switzerland in 2007 and the CO2 emissions (% of total fuel combustion) in Ukraine in 2012?
Provide a short and direct response. 29.29. What is the difference between the CO2 emissions (% of total fuel combustion) in Russian Federation in 2008 and the CO2 emissions (% of total fuel combustion) in Slovak Republic in 2009?
Make the answer very short. -3.37. What is the difference between the CO2 emissions (% of total fuel combustion) of Russian Federation in 2008 and the CO2 emissions (% of total fuel combustion) of Switzerland in 2009?
Give a very brief answer. -25.07. What is the difference between the CO2 emissions (% of total fuel combustion) of Russian Federation in 2008 and the CO2 emissions (% of total fuel combustion) of Ukraine in 2009?
Offer a very short reply. 2.62. What is the difference between the CO2 emissions (% of total fuel combustion) in Slovak Republic in 2008 and the CO2 emissions (% of total fuel combustion) in Switzerland in 2009?
Ensure brevity in your answer.  -20.5. What is the difference between the CO2 emissions (% of total fuel combustion) in Slovak Republic in 2008 and the CO2 emissions (% of total fuel combustion) in Ukraine in 2009?
Offer a very short reply. 7.2. What is the difference between the CO2 emissions (% of total fuel combustion) in Switzerland in 2008 and the CO2 emissions (% of total fuel combustion) in Ukraine in 2009?
Your answer should be compact. 26.85. What is the difference between the CO2 emissions (% of total fuel combustion) in Russian Federation in 2008 and the CO2 emissions (% of total fuel combustion) in Slovak Republic in 2010?
Make the answer very short. -4.75. What is the difference between the CO2 emissions (% of total fuel combustion) of Russian Federation in 2008 and the CO2 emissions (% of total fuel combustion) of Switzerland in 2010?
Ensure brevity in your answer.  -23.58. What is the difference between the CO2 emissions (% of total fuel combustion) in Russian Federation in 2008 and the CO2 emissions (% of total fuel combustion) in Ukraine in 2010?
Make the answer very short. 3.24. What is the difference between the CO2 emissions (% of total fuel combustion) in Slovak Republic in 2008 and the CO2 emissions (% of total fuel combustion) in Switzerland in 2010?
Offer a very short reply. -19.01. What is the difference between the CO2 emissions (% of total fuel combustion) of Slovak Republic in 2008 and the CO2 emissions (% of total fuel combustion) of Ukraine in 2010?
Ensure brevity in your answer.  7.81. What is the difference between the CO2 emissions (% of total fuel combustion) in Switzerland in 2008 and the CO2 emissions (% of total fuel combustion) in Ukraine in 2010?
Provide a short and direct response. 27.46. What is the difference between the CO2 emissions (% of total fuel combustion) in Russian Federation in 2008 and the CO2 emissions (% of total fuel combustion) in Slovak Republic in 2011?
Keep it short and to the point. -5.48. What is the difference between the CO2 emissions (% of total fuel combustion) of Russian Federation in 2008 and the CO2 emissions (% of total fuel combustion) of Switzerland in 2011?
Give a very brief answer. -26.96. What is the difference between the CO2 emissions (% of total fuel combustion) of Russian Federation in 2008 and the CO2 emissions (% of total fuel combustion) of Ukraine in 2011?
Offer a very short reply. 3.91. What is the difference between the CO2 emissions (% of total fuel combustion) in Slovak Republic in 2008 and the CO2 emissions (% of total fuel combustion) in Switzerland in 2011?
Offer a terse response. -22.38. What is the difference between the CO2 emissions (% of total fuel combustion) of Slovak Republic in 2008 and the CO2 emissions (% of total fuel combustion) of Ukraine in 2011?
Keep it short and to the point. 8.48. What is the difference between the CO2 emissions (% of total fuel combustion) in Switzerland in 2008 and the CO2 emissions (% of total fuel combustion) in Ukraine in 2011?
Offer a very short reply. 28.13. What is the difference between the CO2 emissions (% of total fuel combustion) in Russian Federation in 2008 and the CO2 emissions (% of total fuel combustion) in Slovak Republic in 2012?
Provide a succinct answer. -4.73. What is the difference between the CO2 emissions (% of total fuel combustion) in Russian Federation in 2008 and the CO2 emissions (% of total fuel combustion) in Switzerland in 2012?
Your response must be concise. -25.88. What is the difference between the CO2 emissions (% of total fuel combustion) in Russian Federation in 2008 and the CO2 emissions (% of total fuel combustion) in Ukraine in 2012?
Offer a very short reply. 4.62. What is the difference between the CO2 emissions (% of total fuel combustion) of Slovak Republic in 2008 and the CO2 emissions (% of total fuel combustion) of Switzerland in 2012?
Offer a very short reply. -21.31. What is the difference between the CO2 emissions (% of total fuel combustion) of Slovak Republic in 2008 and the CO2 emissions (% of total fuel combustion) of Ukraine in 2012?
Ensure brevity in your answer.  9.19. What is the difference between the CO2 emissions (% of total fuel combustion) of Switzerland in 2008 and the CO2 emissions (% of total fuel combustion) of Ukraine in 2012?
Provide a succinct answer. 28.84. What is the difference between the CO2 emissions (% of total fuel combustion) of Russian Federation in 2009 and the CO2 emissions (% of total fuel combustion) of Slovak Republic in 2010?
Offer a terse response. -4.78. What is the difference between the CO2 emissions (% of total fuel combustion) of Russian Federation in 2009 and the CO2 emissions (% of total fuel combustion) of Switzerland in 2010?
Keep it short and to the point. -23.61. What is the difference between the CO2 emissions (% of total fuel combustion) in Russian Federation in 2009 and the CO2 emissions (% of total fuel combustion) in Ukraine in 2010?
Your answer should be very brief. 3.21. What is the difference between the CO2 emissions (% of total fuel combustion) of Slovak Republic in 2009 and the CO2 emissions (% of total fuel combustion) of Switzerland in 2010?
Your answer should be very brief. -20.21. What is the difference between the CO2 emissions (% of total fuel combustion) of Slovak Republic in 2009 and the CO2 emissions (% of total fuel combustion) of Ukraine in 2010?
Make the answer very short. 6.61. What is the difference between the CO2 emissions (% of total fuel combustion) of Switzerland in 2009 and the CO2 emissions (% of total fuel combustion) of Ukraine in 2010?
Keep it short and to the point. 28.31. What is the difference between the CO2 emissions (% of total fuel combustion) of Russian Federation in 2009 and the CO2 emissions (% of total fuel combustion) of Slovak Republic in 2011?
Offer a very short reply. -5.51. What is the difference between the CO2 emissions (% of total fuel combustion) of Russian Federation in 2009 and the CO2 emissions (% of total fuel combustion) of Switzerland in 2011?
Make the answer very short. -26.99. What is the difference between the CO2 emissions (% of total fuel combustion) in Russian Federation in 2009 and the CO2 emissions (% of total fuel combustion) in Ukraine in 2011?
Give a very brief answer. 3.88. What is the difference between the CO2 emissions (% of total fuel combustion) in Slovak Republic in 2009 and the CO2 emissions (% of total fuel combustion) in Switzerland in 2011?
Your answer should be compact. -23.59. What is the difference between the CO2 emissions (% of total fuel combustion) of Slovak Republic in 2009 and the CO2 emissions (% of total fuel combustion) of Ukraine in 2011?
Make the answer very short. 7.28. What is the difference between the CO2 emissions (% of total fuel combustion) in Switzerland in 2009 and the CO2 emissions (% of total fuel combustion) in Ukraine in 2011?
Your answer should be compact. 28.98. What is the difference between the CO2 emissions (% of total fuel combustion) in Russian Federation in 2009 and the CO2 emissions (% of total fuel combustion) in Slovak Republic in 2012?
Ensure brevity in your answer.  -4.77. What is the difference between the CO2 emissions (% of total fuel combustion) of Russian Federation in 2009 and the CO2 emissions (% of total fuel combustion) of Switzerland in 2012?
Offer a very short reply. -25.92. What is the difference between the CO2 emissions (% of total fuel combustion) in Russian Federation in 2009 and the CO2 emissions (% of total fuel combustion) in Ukraine in 2012?
Give a very brief answer. 4.59. What is the difference between the CO2 emissions (% of total fuel combustion) of Slovak Republic in 2009 and the CO2 emissions (% of total fuel combustion) of Switzerland in 2012?
Make the answer very short. -22.52. What is the difference between the CO2 emissions (% of total fuel combustion) of Slovak Republic in 2009 and the CO2 emissions (% of total fuel combustion) of Ukraine in 2012?
Keep it short and to the point. 7.99. What is the difference between the CO2 emissions (% of total fuel combustion) in Switzerland in 2009 and the CO2 emissions (% of total fuel combustion) in Ukraine in 2012?
Ensure brevity in your answer.  29.69. What is the difference between the CO2 emissions (% of total fuel combustion) in Russian Federation in 2010 and the CO2 emissions (% of total fuel combustion) in Slovak Republic in 2011?
Ensure brevity in your answer.  -5.5. What is the difference between the CO2 emissions (% of total fuel combustion) of Russian Federation in 2010 and the CO2 emissions (% of total fuel combustion) of Switzerland in 2011?
Provide a short and direct response. -26.98. What is the difference between the CO2 emissions (% of total fuel combustion) in Russian Federation in 2010 and the CO2 emissions (% of total fuel combustion) in Ukraine in 2011?
Your answer should be compact. 3.88. What is the difference between the CO2 emissions (% of total fuel combustion) in Slovak Republic in 2010 and the CO2 emissions (% of total fuel combustion) in Switzerland in 2011?
Your answer should be compact. -22.21. What is the difference between the CO2 emissions (% of total fuel combustion) in Slovak Republic in 2010 and the CO2 emissions (% of total fuel combustion) in Ukraine in 2011?
Offer a very short reply. 8.66. What is the difference between the CO2 emissions (% of total fuel combustion) in Switzerland in 2010 and the CO2 emissions (% of total fuel combustion) in Ukraine in 2011?
Provide a short and direct response. 27.49. What is the difference between the CO2 emissions (% of total fuel combustion) in Russian Federation in 2010 and the CO2 emissions (% of total fuel combustion) in Slovak Republic in 2012?
Offer a terse response. -4.76. What is the difference between the CO2 emissions (% of total fuel combustion) of Russian Federation in 2010 and the CO2 emissions (% of total fuel combustion) of Switzerland in 2012?
Offer a terse response. -25.91. What is the difference between the CO2 emissions (% of total fuel combustion) in Russian Federation in 2010 and the CO2 emissions (% of total fuel combustion) in Ukraine in 2012?
Provide a short and direct response. 4.59. What is the difference between the CO2 emissions (% of total fuel combustion) of Slovak Republic in 2010 and the CO2 emissions (% of total fuel combustion) of Switzerland in 2012?
Offer a terse response. -21.14. What is the difference between the CO2 emissions (% of total fuel combustion) in Slovak Republic in 2010 and the CO2 emissions (% of total fuel combustion) in Ukraine in 2012?
Your answer should be compact. 9.37. What is the difference between the CO2 emissions (% of total fuel combustion) of Switzerland in 2010 and the CO2 emissions (% of total fuel combustion) of Ukraine in 2012?
Your answer should be compact. 28.2. What is the difference between the CO2 emissions (% of total fuel combustion) in Russian Federation in 2011 and the CO2 emissions (% of total fuel combustion) in Slovak Republic in 2012?
Make the answer very short. -5.1. What is the difference between the CO2 emissions (% of total fuel combustion) of Russian Federation in 2011 and the CO2 emissions (% of total fuel combustion) of Switzerland in 2012?
Your answer should be compact. -26.26. What is the difference between the CO2 emissions (% of total fuel combustion) of Russian Federation in 2011 and the CO2 emissions (% of total fuel combustion) of Ukraine in 2012?
Give a very brief answer. 4.25. What is the difference between the CO2 emissions (% of total fuel combustion) in Slovak Republic in 2011 and the CO2 emissions (% of total fuel combustion) in Switzerland in 2012?
Make the answer very short. -20.41. What is the difference between the CO2 emissions (% of total fuel combustion) in Slovak Republic in 2011 and the CO2 emissions (% of total fuel combustion) in Ukraine in 2012?
Offer a very short reply. 10.1. What is the difference between the CO2 emissions (% of total fuel combustion) of Switzerland in 2011 and the CO2 emissions (% of total fuel combustion) of Ukraine in 2012?
Provide a succinct answer. 31.57. What is the average CO2 emissions (% of total fuel combustion) in Russian Federation per year?
Make the answer very short. 14.84. What is the average CO2 emissions (% of total fuel combustion) in Slovak Republic per year?
Offer a very short reply. 18.84. What is the average CO2 emissions (% of total fuel combustion) in Switzerland per year?
Provide a short and direct response. 39.59. What is the average CO2 emissions (% of total fuel combustion) of Ukraine per year?
Offer a terse response. 11.18. In the year 2005, what is the difference between the CO2 emissions (% of total fuel combustion) in Russian Federation and CO2 emissions (% of total fuel combustion) in Slovak Republic?
Make the answer very short. -2.44. In the year 2005, what is the difference between the CO2 emissions (% of total fuel combustion) of Russian Federation and CO2 emissions (% of total fuel combustion) of Switzerland?
Keep it short and to the point. -22.38. In the year 2005, what is the difference between the CO2 emissions (% of total fuel combustion) of Russian Federation and CO2 emissions (% of total fuel combustion) of Ukraine?
Make the answer very short. 4.57. In the year 2005, what is the difference between the CO2 emissions (% of total fuel combustion) in Slovak Republic and CO2 emissions (% of total fuel combustion) in Switzerland?
Keep it short and to the point. -19.94. In the year 2005, what is the difference between the CO2 emissions (% of total fuel combustion) of Slovak Republic and CO2 emissions (% of total fuel combustion) of Ukraine?
Provide a short and direct response. 7.01. In the year 2005, what is the difference between the CO2 emissions (% of total fuel combustion) in Switzerland and CO2 emissions (% of total fuel combustion) in Ukraine?
Offer a terse response. 26.95. In the year 2006, what is the difference between the CO2 emissions (% of total fuel combustion) in Russian Federation and CO2 emissions (% of total fuel combustion) in Slovak Republic?
Ensure brevity in your answer.  -1.67. In the year 2006, what is the difference between the CO2 emissions (% of total fuel combustion) in Russian Federation and CO2 emissions (% of total fuel combustion) in Switzerland?
Offer a terse response. -22.93. In the year 2006, what is the difference between the CO2 emissions (% of total fuel combustion) of Russian Federation and CO2 emissions (% of total fuel combustion) of Ukraine?
Keep it short and to the point. 4.85. In the year 2006, what is the difference between the CO2 emissions (% of total fuel combustion) in Slovak Republic and CO2 emissions (% of total fuel combustion) in Switzerland?
Give a very brief answer. -21.26. In the year 2006, what is the difference between the CO2 emissions (% of total fuel combustion) in Slovak Republic and CO2 emissions (% of total fuel combustion) in Ukraine?
Provide a short and direct response. 6.52. In the year 2006, what is the difference between the CO2 emissions (% of total fuel combustion) of Switzerland and CO2 emissions (% of total fuel combustion) of Ukraine?
Provide a succinct answer. 27.78. In the year 2007, what is the difference between the CO2 emissions (% of total fuel combustion) in Russian Federation and CO2 emissions (% of total fuel combustion) in Slovak Republic?
Your response must be concise. -3.37. In the year 2007, what is the difference between the CO2 emissions (% of total fuel combustion) in Russian Federation and CO2 emissions (% of total fuel combustion) in Switzerland?
Your answer should be very brief. -25.41. In the year 2007, what is the difference between the CO2 emissions (% of total fuel combustion) in Russian Federation and CO2 emissions (% of total fuel combustion) in Ukraine?
Give a very brief answer. 4.45. In the year 2007, what is the difference between the CO2 emissions (% of total fuel combustion) of Slovak Republic and CO2 emissions (% of total fuel combustion) of Switzerland?
Your response must be concise. -22.04. In the year 2007, what is the difference between the CO2 emissions (% of total fuel combustion) in Slovak Republic and CO2 emissions (% of total fuel combustion) in Ukraine?
Provide a short and direct response. 7.82. In the year 2007, what is the difference between the CO2 emissions (% of total fuel combustion) in Switzerland and CO2 emissions (% of total fuel combustion) in Ukraine?
Your answer should be very brief. 29.86. In the year 2008, what is the difference between the CO2 emissions (% of total fuel combustion) in Russian Federation and CO2 emissions (% of total fuel combustion) in Slovak Republic?
Offer a terse response. -4.58. In the year 2008, what is the difference between the CO2 emissions (% of total fuel combustion) in Russian Federation and CO2 emissions (% of total fuel combustion) in Switzerland?
Your answer should be very brief. -24.22. In the year 2008, what is the difference between the CO2 emissions (% of total fuel combustion) of Russian Federation and CO2 emissions (% of total fuel combustion) of Ukraine?
Make the answer very short. 2.61. In the year 2008, what is the difference between the CO2 emissions (% of total fuel combustion) of Slovak Republic and CO2 emissions (% of total fuel combustion) of Switzerland?
Offer a very short reply. -19.65. In the year 2008, what is the difference between the CO2 emissions (% of total fuel combustion) of Slovak Republic and CO2 emissions (% of total fuel combustion) of Ukraine?
Your answer should be compact. 7.18. In the year 2008, what is the difference between the CO2 emissions (% of total fuel combustion) in Switzerland and CO2 emissions (% of total fuel combustion) in Ukraine?
Provide a short and direct response. 26.83. In the year 2009, what is the difference between the CO2 emissions (% of total fuel combustion) of Russian Federation and CO2 emissions (% of total fuel combustion) of Slovak Republic?
Give a very brief answer. -3.4. In the year 2009, what is the difference between the CO2 emissions (% of total fuel combustion) of Russian Federation and CO2 emissions (% of total fuel combustion) of Switzerland?
Provide a succinct answer. -25.11. In the year 2009, what is the difference between the CO2 emissions (% of total fuel combustion) of Russian Federation and CO2 emissions (% of total fuel combustion) of Ukraine?
Your answer should be compact. 2.59. In the year 2009, what is the difference between the CO2 emissions (% of total fuel combustion) of Slovak Republic and CO2 emissions (% of total fuel combustion) of Switzerland?
Your answer should be very brief. -21.71. In the year 2009, what is the difference between the CO2 emissions (% of total fuel combustion) in Slovak Republic and CO2 emissions (% of total fuel combustion) in Ukraine?
Offer a terse response. 5.99. In the year 2009, what is the difference between the CO2 emissions (% of total fuel combustion) in Switzerland and CO2 emissions (% of total fuel combustion) in Ukraine?
Make the answer very short. 27.69. In the year 2010, what is the difference between the CO2 emissions (% of total fuel combustion) of Russian Federation and CO2 emissions (% of total fuel combustion) of Slovak Republic?
Give a very brief answer. -4.77. In the year 2010, what is the difference between the CO2 emissions (% of total fuel combustion) in Russian Federation and CO2 emissions (% of total fuel combustion) in Switzerland?
Make the answer very short. -23.61. In the year 2010, what is the difference between the CO2 emissions (% of total fuel combustion) in Russian Federation and CO2 emissions (% of total fuel combustion) in Ukraine?
Provide a short and direct response. 3.21. In the year 2010, what is the difference between the CO2 emissions (% of total fuel combustion) of Slovak Republic and CO2 emissions (% of total fuel combustion) of Switzerland?
Ensure brevity in your answer.  -18.83. In the year 2010, what is the difference between the CO2 emissions (% of total fuel combustion) in Slovak Republic and CO2 emissions (% of total fuel combustion) in Ukraine?
Your response must be concise. 7.99. In the year 2010, what is the difference between the CO2 emissions (% of total fuel combustion) in Switzerland and CO2 emissions (% of total fuel combustion) in Ukraine?
Your response must be concise. 26.82. In the year 2011, what is the difference between the CO2 emissions (% of total fuel combustion) of Russian Federation and CO2 emissions (% of total fuel combustion) of Slovak Republic?
Your answer should be compact. -5.85. In the year 2011, what is the difference between the CO2 emissions (% of total fuel combustion) of Russian Federation and CO2 emissions (% of total fuel combustion) of Switzerland?
Make the answer very short. -27.33. In the year 2011, what is the difference between the CO2 emissions (% of total fuel combustion) in Russian Federation and CO2 emissions (% of total fuel combustion) in Ukraine?
Your answer should be very brief. 3.54. In the year 2011, what is the difference between the CO2 emissions (% of total fuel combustion) in Slovak Republic and CO2 emissions (% of total fuel combustion) in Switzerland?
Your response must be concise. -21.48. In the year 2011, what is the difference between the CO2 emissions (% of total fuel combustion) of Slovak Republic and CO2 emissions (% of total fuel combustion) of Ukraine?
Give a very brief answer. 9.39. In the year 2011, what is the difference between the CO2 emissions (% of total fuel combustion) of Switzerland and CO2 emissions (% of total fuel combustion) of Ukraine?
Keep it short and to the point. 30.86. In the year 2012, what is the difference between the CO2 emissions (% of total fuel combustion) of Russian Federation and CO2 emissions (% of total fuel combustion) of Slovak Republic?
Provide a succinct answer. -5.9. In the year 2012, what is the difference between the CO2 emissions (% of total fuel combustion) of Russian Federation and CO2 emissions (% of total fuel combustion) of Switzerland?
Your answer should be very brief. -27.05. In the year 2012, what is the difference between the CO2 emissions (% of total fuel combustion) of Russian Federation and CO2 emissions (% of total fuel combustion) of Ukraine?
Your answer should be compact. 3.45. In the year 2012, what is the difference between the CO2 emissions (% of total fuel combustion) in Slovak Republic and CO2 emissions (% of total fuel combustion) in Switzerland?
Your answer should be very brief. -21.15. In the year 2012, what is the difference between the CO2 emissions (% of total fuel combustion) of Slovak Republic and CO2 emissions (% of total fuel combustion) of Ukraine?
Provide a succinct answer. 9.35. In the year 2012, what is the difference between the CO2 emissions (% of total fuel combustion) in Switzerland and CO2 emissions (% of total fuel combustion) in Ukraine?
Make the answer very short. 30.5. What is the ratio of the CO2 emissions (% of total fuel combustion) in Slovak Republic in 2005 to that in 2006?
Your answer should be compact. 1.05. What is the ratio of the CO2 emissions (% of total fuel combustion) in Switzerland in 2005 to that in 2006?
Your answer should be very brief. 0.98. What is the ratio of the CO2 emissions (% of total fuel combustion) of Ukraine in 2005 to that in 2006?
Make the answer very short. 1.03. What is the ratio of the CO2 emissions (% of total fuel combustion) of Slovak Republic in 2005 to that in 2007?
Your answer should be compact. 0.94. What is the ratio of the CO2 emissions (% of total fuel combustion) in Switzerland in 2005 to that in 2007?
Provide a succinct answer. 0.92. What is the ratio of the CO2 emissions (% of total fuel combustion) of Ukraine in 2005 to that in 2007?
Offer a very short reply. 0.98. What is the ratio of the CO2 emissions (% of total fuel combustion) in Russian Federation in 2005 to that in 2008?
Offer a very short reply. 0.94. What is the ratio of the CO2 emissions (% of total fuel combustion) in Switzerland in 2005 to that in 2008?
Give a very brief answer. 0.93. What is the ratio of the CO2 emissions (% of total fuel combustion) of Ukraine in 2005 to that in 2008?
Offer a terse response. 0.78. What is the ratio of the CO2 emissions (% of total fuel combustion) in Russian Federation in 2005 to that in 2009?
Keep it short and to the point. 0.95. What is the ratio of the CO2 emissions (% of total fuel combustion) in Slovak Republic in 2005 to that in 2009?
Provide a succinct answer. 0.9. What is the ratio of the CO2 emissions (% of total fuel combustion) in Switzerland in 2005 to that in 2009?
Your response must be concise. 0.91. What is the ratio of the CO2 emissions (% of total fuel combustion) in Ukraine in 2005 to that in 2009?
Your response must be concise. 0.78. What is the ratio of the CO2 emissions (% of total fuel combustion) in Russian Federation in 2005 to that in 2010?
Offer a terse response. 0.95. What is the ratio of the CO2 emissions (% of total fuel combustion) in Slovak Republic in 2005 to that in 2010?
Offer a very short reply. 0.84. What is the ratio of the CO2 emissions (% of total fuel combustion) in Switzerland in 2005 to that in 2010?
Offer a very short reply. 0.95. What is the ratio of the CO2 emissions (% of total fuel combustion) of Ukraine in 2005 to that in 2010?
Your response must be concise. 0.82. What is the ratio of the CO2 emissions (% of total fuel combustion) of Russian Federation in 2005 to that in 2011?
Your answer should be very brief. 0.97. What is the ratio of the CO2 emissions (% of total fuel combustion) in Slovak Republic in 2005 to that in 2011?
Your answer should be very brief. 0.81. What is the ratio of the CO2 emissions (% of total fuel combustion) in Switzerland in 2005 to that in 2011?
Your answer should be very brief. 0.87. What is the ratio of the CO2 emissions (% of total fuel combustion) in Ukraine in 2005 to that in 2011?
Your answer should be compact. 0.87. What is the ratio of the CO2 emissions (% of total fuel combustion) in Russian Federation in 2005 to that in 2012?
Your response must be concise. 1.02. What is the ratio of the CO2 emissions (% of total fuel combustion) of Slovak Republic in 2005 to that in 2012?
Keep it short and to the point. 0.84. What is the ratio of the CO2 emissions (% of total fuel combustion) in Switzerland in 2005 to that in 2012?
Provide a short and direct response. 0.89. What is the ratio of the CO2 emissions (% of total fuel combustion) of Ukraine in 2005 to that in 2012?
Make the answer very short. 0.93. What is the ratio of the CO2 emissions (% of total fuel combustion) of Russian Federation in 2006 to that in 2007?
Keep it short and to the point. 0.99. What is the ratio of the CO2 emissions (% of total fuel combustion) of Slovak Republic in 2006 to that in 2007?
Your answer should be very brief. 0.9. What is the ratio of the CO2 emissions (% of total fuel combustion) of Switzerland in 2006 to that in 2007?
Your answer should be compact. 0.94. What is the ratio of the CO2 emissions (% of total fuel combustion) of Ukraine in 2006 to that in 2007?
Your answer should be very brief. 0.95. What is the ratio of the CO2 emissions (% of total fuel combustion) of Russian Federation in 2006 to that in 2008?
Give a very brief answer. 0.95. What is the ratio of the CO2 emissions (% of total fuel combustion) in Slovak Republic in 2006 to that in 2008?
Offer a terse response. 0.81. What is the ratio of the CO2 emissions (% of total fuel combustion) in Switzerland in 2006 to that in 2008?
Provide a succinct answer. 0.95. What is the ratio of the CO2 emissions (% of total fuel combustion) in Ukraine in 2006 to that in 2008?
Offer a terse response. 0.76. What is the ratio of the CO2 emissions (% of total fuel combustion) of Russian Federation in 2006 to that in 2009?
Provide a short and direct response. 0.95. What is the ratio of the CO2 emissions (% of total fuel combustion) of Slovak Republic in 2006 to that in 2009?
Give a very brief answer. 0.86. What is the ratio of the CO2 emissions (% of total fuel combustion) in Switzerland in 2006 to that in 2009?
Give a very brief answer. 0.93. What is the ratio of the CO2 emissions (% of total fuel combustion) in Ukraine in 2006 to that in 2009?
Give a very brief answer. 0.76. What is the ratio of the CO2 emissions (% of total fuel combustion) of Russian Federation in 2006 to that in 2010?
Offer a terse response. 0.95. What is the ratio of the CO2 emissions (% of total fuel combustion) of Slovak Republic in 2006 to that in 2010?
Provide a succinct answer. 0.81. What is the ratio of the CO2 emissions (% of total fuel combustion) in Switzerland in 2006 to that in 2010?
Provide a succinct answer. 0.96. What is the ratio of the CO2 emissions (% of total fuel combustion) of Ukraine in 2006 to that in 2010?
Keep it short and to the point. 0.8. What is the ratio of the CO2 emissions (% of total fuel combustion) in Russian Federation in 2006 to that in 2011?
Provide a short and direct response. 0.97. What is the ratio of the CO2 emissions (% of total fuel combustion) in Slovak Republic in 2006 to that in 2011?
Make the answer very short. 0.78. What is the ratio of the CO2 emissions (% of total fuel combustion) of Switzerland in 2006 to that in 2011?
Offer a very short reply. 0.89. What is the ratio of the CO2 emissions (% of total fuel combustion) in Ukraine in 2006 to that in 2011?
Offer a very short reply. 0.84. What is the ratio of the CO2 emissions (% of total fuel combustion) of Russian Federation in 2006 to that in 2012?
Ensure brevity in your answer.  1.02. What is the ratio of the CO2 emissions (% of total fuel combustion) in Slovak Republic in 2006 to that in 2012?
Provide a succinct answer. 0.81. What is the ratio of the CO2 emissions (% of total fuel combustion) in Switzerland in 2006 to that in 2012?
Offer a very short reply. 0.91. What is the ratio of the CO2 emissions (% of total fuel combustion) of Ukraine in 2006 to that in 2012?
Make the answer very short. 0.9. What is the ratio of the CO2 emissions (% of total fuel combustion) of Slovak Republic in 2007 to that in 2008?
Offer a very short reply. 0.9. What is the ratio of the CO2 emissions (% of total fuel combustion) in Switzerland in 2007 to that in 2008?
Keep it short and to the point. 1.01. What is the ratio of the CO2 emissions (% of total fuel combustion) of Ukraine in 2007 to that in 2008?
Your response must be concise. 0.8. What is the ratio of the CO2 emissions (% of total fuel combustion) in Russian Federation in 2007 to that in 2009?
Offer a very short reply. 0.95. What is the ratio of the CO2 emissions (% of total fuel combustion) of Slovak Republic in 2007 to that in 2009?
Your answer should be very brief. 0.96. What is the ratio of the CO2 emissions (% of total fuel combustion) of Ukraine in 2007 to that in 2009?
Your response must be concise. 0.8. What is the ratio of the CO2 emissions (% of total fuel combustion) in Russian Federation in 2007 to that in 2010?
Give a very brief answer. 0.95. What is the ratio of the CO2 emissions (% of total fuel combustion) in Slovak Republic in 2007 to that in 2010?
Offer a very short reply. 0.89. What is the ratio of the CO2 emissions (% of total fuel combustion) of Switzerland in 2007 to that in 2010?
Give a very brief answer. 1.03. What is the ratio of the CO2 emissions (% of total fuel combustion) of Ukraine in 2007 to that in 2010?
Your answer should be compact. 0.84. What is the ratio of the CO2 emissions (% of total fuel combustion) of Russian Federation in 2007 to that in 2011?
Give a very brief answer. 0.98. What is the ratio of the CO2 emissions (% of total fuel combustion) in Slovak Republic in 2007 to that in 2011?
Make the answer very short. 0.86. What is the ratio of the CO2 emissions (% of total fuel combustion) of Switzerland in 2007 to that in 2011?
Give a very brief answer. 0.95. What is the ratio of the CO2 emissions (% of total fuel combustion) in Ukraine in 2007 to that in 2011?
Make the answer very short. 0.89. What is the ratio of the CO2 emissions (% of total fuel combustion) of Russian Federation in 2007 to that in 2012?
Provide a succinct answer. 1.03. What is the ratio of the CO2 emissions (% of total fuel combustion) of Slovak Republic in 2007 to that in 2012?
Offer a very short reply. 0.9. What is the ratio of the CO2 emissions (% of total fuel combustion) of Switzerland in 2007 to that in 2012?
Provide a succinct answer. 0.97. What is the ratio of the CO2 emissions (% of total fuel combustion) in Ukraine in 2007 to that in 2012?
Offer a terse response. 0.95. What is the ratio of the CO2 emissions (% of total fuel combustion) in Slovak Republic in 2008 to that in 2009?
Offer a very short reply. 1.06. What is the ratio of the CO2 emissions (% of total fuel combustion) in Ukraine in 2008 to that in 2009?
Keep it short and to the point. 1. What is the ratio of the CO2 emissions (% of total fuel combustion) in Russian Federation in 2008 to that in 2010?
Give a very brief answer. 1. What is the ratio of the CO2 emissions (% of total fuel combustion) in Switzerland in 2008 to that in 2010?
Offer a very short reply. 1.02. What is the ratio of the CO2 emissions (% of total fuel combustion) of Ukraine in 2008 to that in 2010?
Offer a very short reply. 1.05. What is the ratio of the CO2 emissions (% of total fuel combustion) in Russian Federation in 2008 to that in 2011?
Ensure brevity in your answer.  1.02. What is the ratio of the CO2 emissions (% of total fuel combustion) of Slovak Republic in 2008 to that in 2011?
Your answer should be very brief. 0.96. What is the ratio of the CO2 emissions (% of total fuel combustion) of Switzerland in 2008 to that in 2011?
Your answer should be compact. 0.94. What is the ratio of the CO2 emissions (% of total fuel combustion) of Ukraine in 2008 to that in 2011?
Give a very brief answer. 1.11. What is the ratio of the CO2 emissions (% of total fuel combustion) of Russian Federation in 2008 to that in 2012?
Your response must be concise. 1.08. What is the ratio of the CO2 emissions (% of total fuel combustion) in Switzerland in 2008 to that in 2012?
Keep it short and to the point. 0.96. What is the ratio of the CO2 emissions (% of total fuel combustion) in Ukraine in 2008 to that in 2012?
Offer a terse response. 1.19. What is the ratio of the CO2 emissions (% of total fuel combustion) of Slovak Republic in 2009 to that in 2010?
Your response must be concise. 0.93. What is the ratio of the CO2 emissions (% of total fuel combustion) in Switzerland in 2009 to that in 2010?
Your answer should be very brief. 1.04. What is the ratio of the CO2 emissions (% of total fuel combustion) in Ukraine in 2009 to that in 2010?
Provide a short and direct response. 1.05. What is the ratio of the CO2 emissions (% of total fuel combustion) of Russian Federation in 2009 to that in 2011?
Offer a very short reply. 1.02. What is the ratio of the CO2 emissions (% of total fuel combustion) in Slovak Republic in 2009 to that in 2011?
Make the answer very short. 0.9. What is the ratio of the CO2 emissions (% of total fuel combustion) in Switzerland in 2009 to that in 2011?
Provide a succinct answer. 0.96. What is the ratio of the CO2 emissions (% of total fuel combustion) in Ukraine in 2009 to that in 2011?
Offer a very short reply. 1.11. What is the ratio of the CO2 emissions (% of total fuel combustion) of Russian Federation in 2009 to that in 2012?
Give a very brief answer. 1.08. What is the ratio of the CO2 emissions (% of total fuel combustion) in Slovak Republic in 2009 to that in 2012?
Make the answer very short. 0.93. What is the ratio of the CO2 emissions (% of total fuel combustion) of Switzerland in 2009 to that in 2012?
Ensure brevity in your answer.  0.98. What is the ratio of the CO2 emissions (% of total fuel combustion) in Ukraine in 2009 to that in 2012?
Offer a terse response. 1.19. What is the ratio of the CO2 emissions (% of total fuel combustion) of Russian Federation in 2010 to that in 2011?
Provide a short and direct response. 1.02. What is the ratio of the CO2 emissions (% of total fuel combustion) in Slovak Republic in 2010 to that in 2011?
Give a very brief answer. 0.96. What is the ratio of the CO2 emissions (% of total fuel combustion) of Switzerland in 2010 to that in 2011?
Your answer should be compact. 0.92. What is the ratio of the CO2 emissions (% of total fuel combustion) of Ukraine in 2010 to that in 2011?
Your answer should be very brief. 1.06. What is the ratio of the CO2 emissions (% of total fuel combustion) in Russian Federation in 2010 to that in 2012?
Offer a very short reply. 1.08. What is the ratio of the CO2 emissions (% of total fuel combustion) of Slovak Republic in 2010 to that in 2012?
Provide a short and direct response. 1. What is the ratio of the CO2 emissions (% of total fuel combustion) in Switzerland in 2010 to that in 2012?
Provide a short and direct response. 0.94. What is the ratio of the CO2 emissions (% of total fuel combustion) in Ukraine in 2010 to that in 2012?
Your answer should be compact. 1.13. What is the ratio of the CO2 emissions (% of total fuel combustion) of Russian Federation in 2011 to that in 2012?
Provide a succinct answer. 1.06. What is the ratio of the CO2 emissions (% of total fuel combustion) in Slovak Republic in 2011 to that in 2012?
Your answer should be very brief. 1.04. What is the ratio of the CO2 emissions (% of total fuel combustion) in Ukraine in 2011 to that in 2012?
Your answer should be very brief. 1.07. What is the difference between the highest and the second highest CO2 emissions (% of total fuel combustion) of Russian Federation?
Provide a succinct answer. 0.03. What is the difference between the highest and the second highest CO2 emissions (% of total fuel combustion) of Slovak Republic?
Provide a succinct answer. 0.73. What is the difference between the highest and the second highest CO2 emissions (% of total fuel combustion) of Switzerland?
Keep it short and to the point. 1.07. What is the difference between the highest and the second highest CO2 emissions (% of total fuel combustion) of Ukraine?
Your answer should be compact. 0.01. What is the difference between the highest and the lowest CO2 emissions (% of total fuel combustion) in Russian Federation?
Keep it short and to the point. 1.16. What is the difference between the highest and the lowest CO2 emissions (% of total fuel combustion) in Slovak Republic?
Ensure brevity in your answer.  4.64. What is the difference between the highest and the lowest CO2 emissions (% of total fuel combustion) of Switzerland?
Offer a terse response. 5.43. What is the difference between the highest and the lowest CO2 emissions (% of total fuel combustion) of Ukraine?
Ensure brevity in your answer.  3.08. 